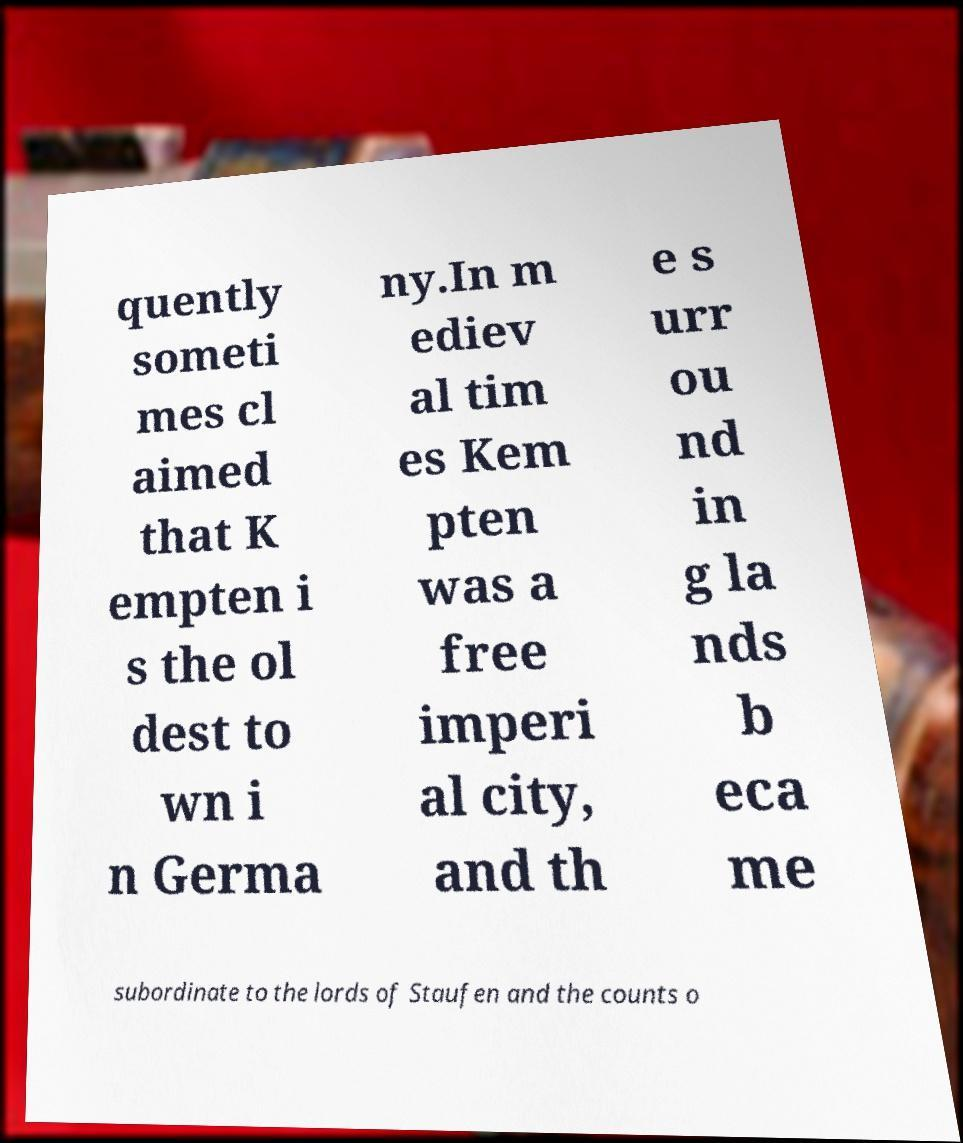Can you read and provide the text displayed in the image?This photo seems to have some interesting text. Can you extract and type it out for me? quently someti mes cl aimed that K empten i s the ol dest to wn i n Germa ny.In m ediev al tim es Kem pten was a free imperi al city, and th e s urr ou nd in g la nds b eca me subordinate to the lords of Staufen and the counts o 